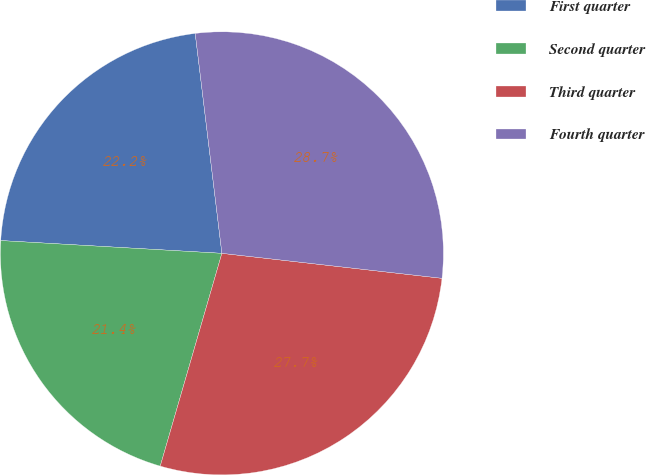Convert chart to OTSL. <chart><loc_0><loc_0><loc_500><loc_500><pie_chart><fcel>First quarter<fcel>Second quarter<fcel>Third quarter<fcel>Fourth quarter<nl><fcel>22.16%<fcel>21.43%<fcel>27.69%<fcel>28.72%<nl></chart> 